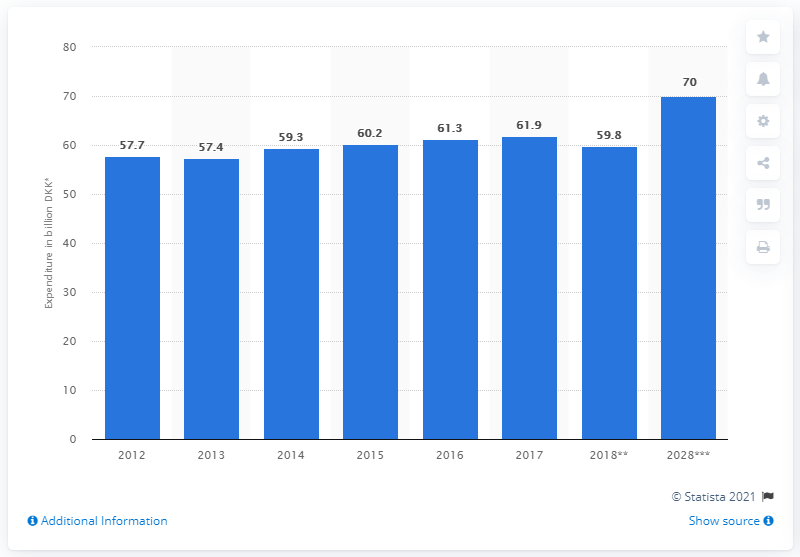Indicate a few pertinent items in this graphic. There was an estimated decrease of 59.8 outbound tourists from Denmark in 2018. In 2017, outbound tourists from Denmark spent a total of 61.9 billion Danish kroner in other countries. 